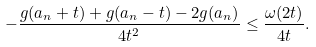<formula> <loc_0><loc_0><loc_500><loc_500>- \frac { g ( a _ { n } + t ) + g ( a _ { n } - t ) - 2 g ( a _ { n } ) } { 4 t ^ { 2 } } \leq \frac { \omega ( 2 t ) } { 4 t } .</formula> 